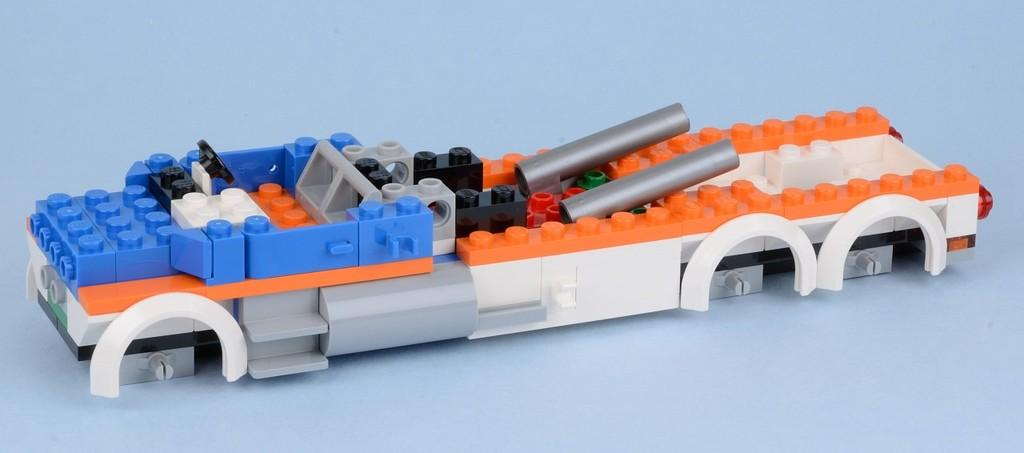What is the main object in the image? There is a toy in the image. What material is the toy made of? The toy is made with blocks. What type of hen can be seen laying cream in the image? There is no hen or cream present in the image; it only features a toy made with blocks. 